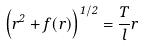<formula> <loc_0><loc_0><loc_500><loc_500>\left ( \dot { r } ^ { 2 } + f ( r ) \right ) ^ { 1 / 2 } = \frac { T } { l } r</formula> 